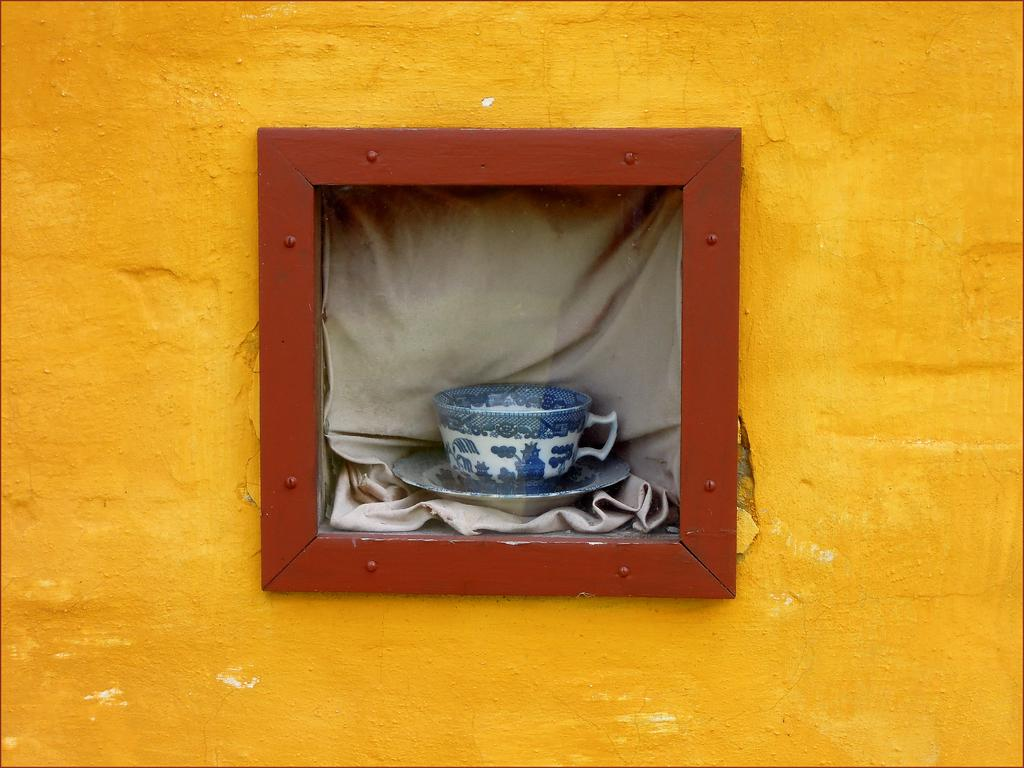What is present on the wall in the image? There is a window on the wall in the image. How is the window covered? The window is covered with a curtain. What items are placed on the curtain? There is a cup and a saucer on the curtain. Can you describe the position of the window on the wall? The provided facts do not specify the position of the window on the wall. Who won the competition mentioned by the aunt in the image? There is no mention of a competition or an aunt in the image. 